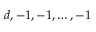Convert formula to latex. <formula><loc_0><loc_0><loc_500><loc_500>d , - 1 , - 1 , \dots , - 1</formula> 